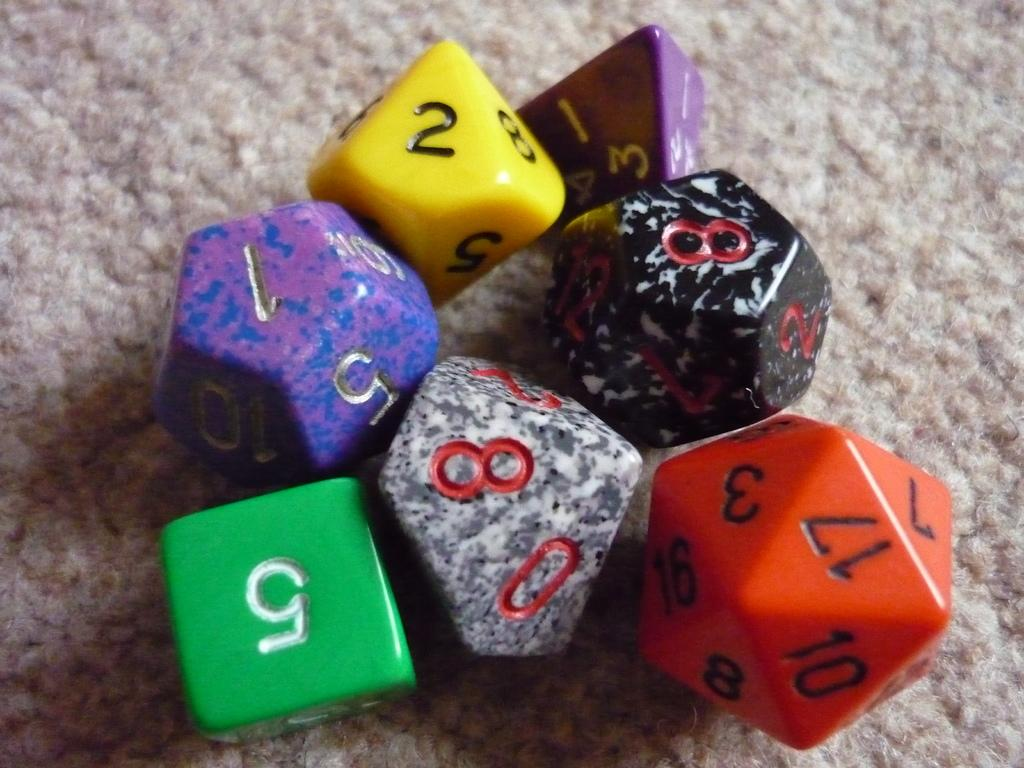What objects are present in the image? There are dice in the image. Can you describe the dice in more detail? The dice have different colors and different shapes. Where are the dice located in the image? The dice are on the floor. What type of goat can be seen playing with the dice in the image? There is no goat present in the image, and therefore no such activity can be observed. 